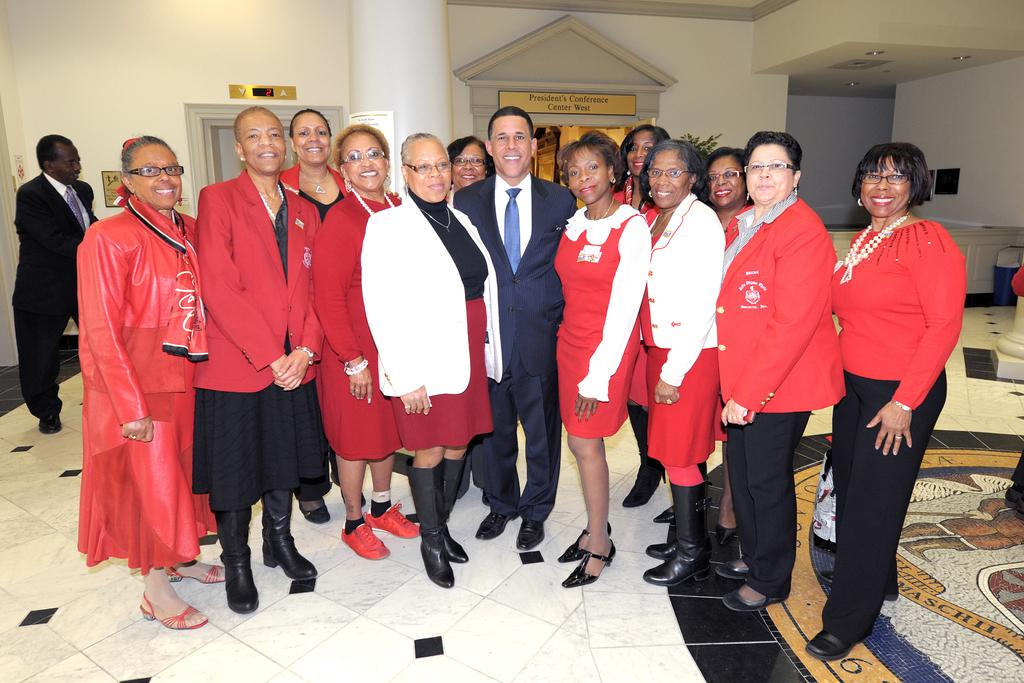Who or what is present in the image? There are people in the image. What are the people wearing? The people are wearing red color dress. What can be seen in the background of the image? There is a pillar and a wall in the backdrop of the image. What type of smoke can be seen coming from the rabbits in the image? There are no rabbits present in the image, and therefore no smoke can be seen coming from them. 